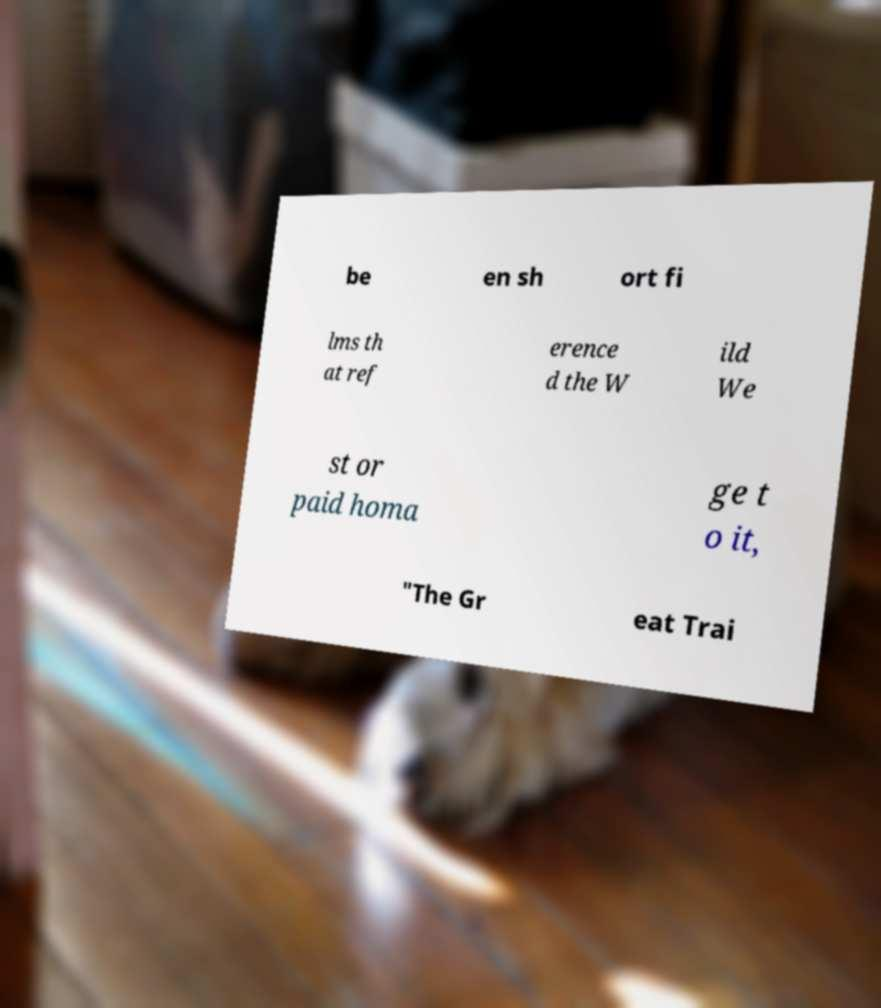Can you read and provide the text displayed in the image?This photo seems to have some interesting text. Can you extract and type it out for me? be en sh ort fi lms th at ref erence d the W ild We st or paid homa ge t o it, "The Gr eat Trai 